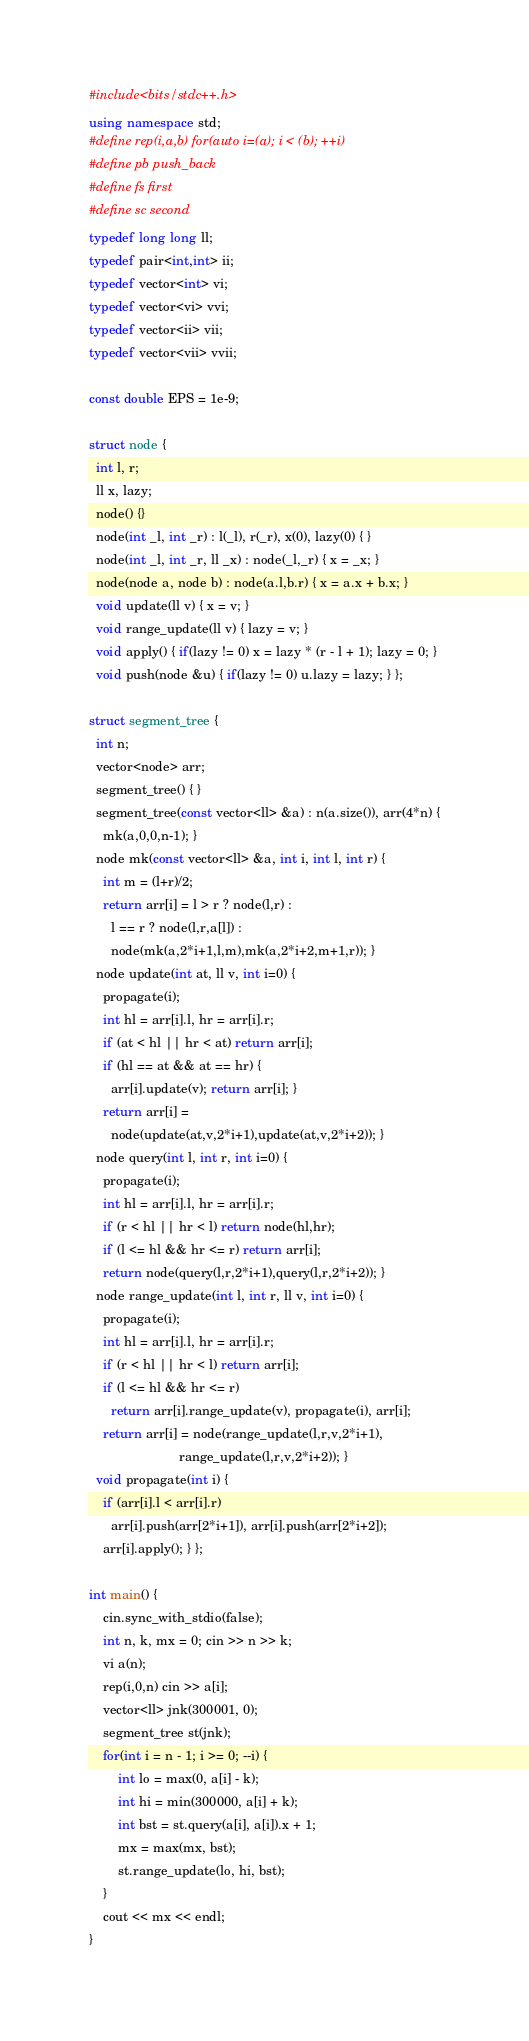Convert code to text. <code><loc_0><loc_0><loc_500><loc_500><_C++_>#include<bits/stdc++.h>
using namespace std;
#define rep(i,a,b) for(auto i=(a); i < (b); ++i)
#define pb push_back
#define fs first
#define sc second
typedef long long ll;
typedef pair<int,int> ii;
typedef vector<int> vi;
typedef vector<vi> vvi;
typedef vector<ii> vii;
typedef vector<vii> vvii;

const double EPS = 1e-9;

struct node {
  int l, r;
  ll x, lazy;
  node() {}
  node(int _l, int _r) : l(_l), r(_r), x(0), lazy(0) { }
  node(int _l, int _r, ll _x) : node(_l,_r) { x = _x; }
  node(node a, node b) : node(a.l,b.r) { x = a.x + b.x; }
  void update(ll v) { x = v; }
  void range_update(ll v) { lazy = v; }
  void apply() { if(lazy != 0) x = lazy * (r - l + 1); lazy = 0; }
  void push(node &u) { if(lazy != 0) u.lazy = lazy; } };

struct segment_tree {
  int n;
  vector<node> arr;
  segment_tree() { }
  segment_tree(const vector<ll> &a) : n(a.size()), arr(4*n) {
    mk(a,0,0,n-1); }
  node mk(const vector<ll> &a, int i, int l, int r) {
    int m = (l+r)/2;
    return arr[i] = l > r ? node(l,r) :
      l == r ? node(l,r,a[l]) :
      node(mk(a,2*i+1,l,m),mk(a,2*i+2,m+1,r)); }
  node update(int at, ll v, int i=0) {
    propagate(i);
    int hl = arr[i].l, hr = arr[i].r;
    if (at < hl || hr < at) return arr[i];
    if (hl == at && at == hr) {
      arr[i].update(v); return arr[i]; }
    return arr[i] =
      node(update(at,v,2*i+1),update(at,v,2*i+2)); }
  node query(int l, int r, int i=0) {
    propagate(i);
    int hl = arr[i].l, hr = arr[i].r;
    if (r < hl || hr < l) return node(hl,hr);
    if (l <= hl && hr <= r) return arr[i];
    return node(query(l,r,2*i+1),query(l,r,2*i+2)); }
  node range_update(int l, int r, ll v, int i=0) {
    propagate(i);
    int hl = arr[i].l, hr = arr[i].r;
    if (r < hl || hr < l) return arr[i];
    if (l <= hl && hr <= r)
      return arr[i].range_update(v), propagate(i), arr[i];
    return arr[i] = node(range_update(l,r,v,2*i+1),
                         range_update(l,r,v,2*i+2)); }
  void propagate(int i) {
    if (arr[i].l < arr[i].r)
      arr[i].push(arr[2*i+1]), arr[i].push(arr[2*i+2]);
    arr[i].apply(); } };

int main() {
    cin.sync_with_stdio(false);
    int n, k, mx = 0; cin >> n >> k;
    vi a(n);
    rep(i,0,n) cin >> a[i];
    vector<ll> jnk(300001, 0);
    segment_tree st(jnk);
    for(int i = n - 1; i >= 0; --i) {
        int lo = max(0, a[i] - k);
        int hi = min(300000, a[i] + k);
        int bst = st.query(a[i], a[i]).x + 1;
        mx = max(mx, bst);
        st.range_update(lo, hi, bst);
    }
    cout << mx << endl;
}
</code> 